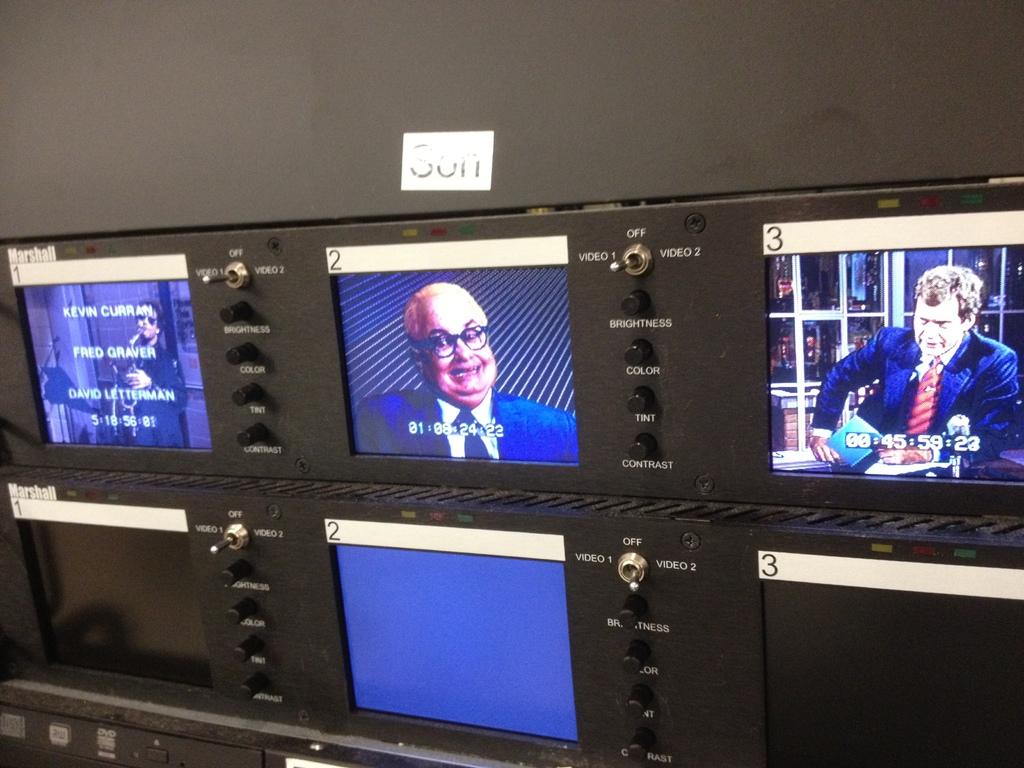What is the time stamp on the tv #3 playing on the far right?
Give a very brief answer. 00:45:59:23. Is there an off switch on these?
Your answer should be compact. Yes. 